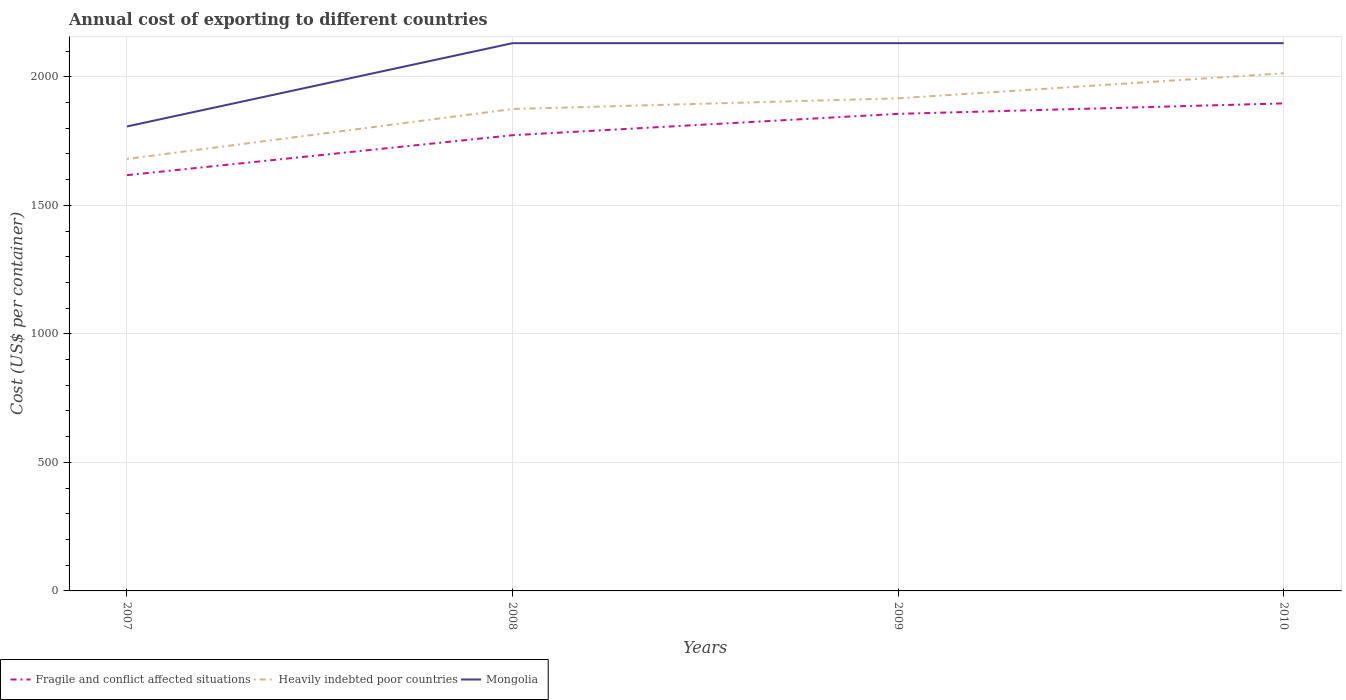Is the number of lines equal to the number of legend labels?
Your answer should be compact. Yes. Across all years, what is the maximum total annual cost of exporting in Mongolia?
Ensure brevity in your answer.  1807. In which year was the total annual cost of exporting in Heavily indebted poor countries maximum?
Your answer should be very brief. 2007. What is the total total annual cost of exporting in Heavily indebted poor countries in the graph?
Offer a very short reply. -235.92. What is the difference between the highest and the second highest total annual cost of exporting in Heavily indebted poor countries?
Your response must be concise. 333.29. Is the total annual cost of exporting in Fragile and conflict affected situations strictly greater than the total annual cost of exporting in Mongolia over the years?
Keep it short and to the point. Yes. How many years are there in the graph?
Offer a very short reply. 4. Does the graph contain any zero values?
Your answer should be very brief. No. Does the graph contain grids?
Your response must be concise. Yes. What is the title of the graph?
Your answer should be compact. Annual cost of exporting to different countries. What is the label or title of the Y-axis?
Provide a short and direct response. Cost (US$ per container). What is the Cost (US$ per container) in Fragile and conflict affected situations in 2007?
Your answer should be very brief. 1617.52. What is the Cost (US$ per container) in Heavily indebted poor countries in 2007?
Provide a short and direct response. 1680.55. What is the Cost (US$ per container) in Mongolia in 2007?
Your answer should be very brief. 1807. What is the Cost (US$ per container) in Fragile and conflict affected situations in 2008?
Ensure brevity in your answer.  1772.86. What is the Cost (US$ per container) in Heavily indebted poor countries in 2008?
Make the answer very short. 1874.84. What is the Cost (US$ per container) in Mongolia in 2008?
Provide a succinct answer. 2131. What is the Cost (US$ per container) in Fragile and conflict affected situations in 2009?
Provide a short and direct response. 1856. What is the Cost (US$ per container) of Heavily indebted poor countries in 2009?
Your answer should be compact. 1916.47. What is the Cost (US$ per container) of Mongolia in 2009?
Your answer should be compact. 2131. What is the Cost (US$ per container) in Fragile and conflict affected situations in 2010?
Provide a short and direct response. 1896.7. What is the Cost (US$ per container) of Heavily indebted poor countries in 2010?
Your response must be concise. 2013.84. What is the Cost (US$ per container) in Mongolia in 2010?
Your answer should be compact. 2131. Across all years, what is the maximum Cost (US$ per container) in Fragile and conflict affected situations?
Your answer should be very brief. 1896.7. Across all years, what is the maximum Cost (US$ per container) of Heavily indebted poor countries?
Provide a succinct answer. 2013.84. Across all years, what is the maximum Cost (US$ per container) in Mongolia?
Offer a very short reply. 2131. Across all years, what is the minimum Cost (US$ per container) of Fragile and conflict affected situations?
Offer a terse response. 1617.52. Across all years, what is the minimum Cost (US$ per container) in Heavily indebted poor countries?
Provide a succinct answer. 1680.55. Across all years, what is the minimum Cost (US$ per container) in Mongolia?
Your answer should be compact. 1807. What is the total Cost (US$ per container) of Fragile and conflict affected situations in the graph?
Offer a terse response. 7143.08. What is the total Cost (US$ per container) in Heavily indebted poor countries in the graph?
Your response must be concise. 7485.71. What is the total Cost (US$ per container) in Mongolia in the graph?
Your answer should be compact. 8200. What is the difference between the Cost (US$ per container) in Fragile and conflict affected situations in 2007 and that in 2008?
Provide a succinct answer. -155.34. What is the difference between the Cost (US$ per container) of Heavily indebted poor countries in 2007 and that in 2008?
Offer a terse response. -194.29. What is the difference between the Cost (US$ per container) of Mongolia in 2007 and that in 2008?
Your response must be concise. -324. What is the difference between the Cost (US$ per container) of Fragile and conflict affected situations in 2007 and that in 2009?
Provide a succinct answer. -238.48. What is the difference between the Cost (US$ per container) of Heavily indebted poor countries in 2007 and that in 2009?
Ensure brevity in your answer.  -235.92. What is the difference between the Cost (US$ per container) of Mongolia in 2007 and that in 2009?
Make the answer very short. -324. What is the difference between the Cost (US$ per container) in Fragile and conflict affected situations in 2007 and that in 2010?
Offer a very short reply. -279.18. What is the difference between the Cost (US$ per container) of Heavily indebted poor countries in 2007 and that in 2010?
Offer a very short reply. -333.29. What is the difference between the Cost (US$ per container) in Mongolia in 2007 and that in 2010?
Your answer should be compact. -324. What is the difference between the Cost (US$ per container) of Fragile and conflict affected situations in 2008 and that in 2009?
Provide a short and direct response. -83.14. What is the difference between the Cost (US$ per container) in Heavily indebted poor countries in 2008 and that in 2009?
Your answer should be very brief. -41.63. What is the difference between the Cost (US$ per container) in Fragile and conflict affected situations in 2008 and that in 2010?
Provide a succinct answer. -123.84. What is the difference between the Cost (US$ per container) in Heavily indebted poor countries in 2008 and that in 2010?
Provide a short and direct response. -139. What is the difference between the Cost (US$ per container) of Fragile and conflict affected situations in 2009 and that in 2010?
Make the answer very short. -40.7. What is the difference between the Cost (US$ per container) of Heavily indebted poor countries in 2009 and that in 2010?
Provide a succinct answer. -97.37. What is the difference between the Cost (US$ per container) in Fragile and conflict affected situations in 2007 and the Cost (US$ per container) in Heavily indebted poor countries in 2008?
Ensure brevity in your answer.  -257.32. What is the difference between the Cost (US$ per container) of Fragile and conflict affected situations in 2007 and the Cost (US$ per container) of Mongolia in 2008?
Provide a short and direct response. -513.48. What is the difference between the Cost (US$ per container) in Heavily indebted poor countries in 2007 and the Cost (US$ per container) in Mongolia in 2008?
Your answer should be very brief. -450.45. What is the difference between the Cost (US$ per container) in Fragile and conflict affected situations in 2007 and the Cost (US$ per container) in Heavily indebted poor countries in 2009?
Provide a short and direct response. -298.96. What is the difference between the Cost (US$ per container) in Fragile and conflict affected situations in 2007 and the Cost (US$ per container) in Mongolia in 2009?
Provide a short and direct response. -513.48. What is the difference between the Cost (US$ per container) in Heavily indebted poor countries in 2007 and the Cost (US$ per container) in Mongolia in 2009?
Your answer should be very brief. -450.45. What is the difference between the Cost (US$ per container) of Fragile and conflict affected situations in 2007 and the Cost (US$ per container) of Heavily indebted poor countries in 2010?
Provide a short and direct response. -396.32. What is the difference between the Cost (US$ per container) in Fragile and conflict affected situations in 2007 and the Cost (US$ per container) in Mongolia in 2010?
Your response must be concise. -513.48. What is the difference between the Cost (US$ per container) of Heavily indebted poor countries in 2007 and the Cost (US$ per container) of Mongolia in 2010?
Provide a short and direct response. -450.45. What is the difference between the Cost (US$ per container) of Fragile and conflict affected situations in 2008 and the Cost (US$ per container) of Heavily indebted poor countries in 2009?
Ensure brevity in your answer.  -143.61. What is the difference between the Cost (US$ per container) of Fragile and conflict affected situations in 2008 and the Cost (US$ per container) of Mongolia in 2009?
Your answer should be very brief. -358.14. What is the difference between the Cost (US$ per container) in Heavily indebted poor countries in 2008 and the Cost (US$ per container) in Mongolia in 2009?
Your response must be concise. -256.16. What is the difference between the Cost (US$ per container) of Fragile and conflict affected situations in 2008 and the Cost (US$ per container) of Heavily indebted poor countries in 2010?
Make the answer very short. -240.98. What is the difference between the Cost (US$ per container) of Fragile and conflict affected situations in 2008 and the Cost (US$ per container) of Mongolia in 2010?
Your response must be concise. -358.14. What is the difference between the Cost (US$ per container) in Heavily indebted poor countries in 2008 and the Cost (US$ per container) in Mongolia in 2010?
Keep it short and to the point. -256.16. What is the difference between the Cost (US$ per container) of Fragile and conflict affected situations in 2009 and the Cost (US$ per container) of Heavily indebted poor countries in 2010?
Offer a very short reply. -157.84. What is the difference between the Cost (US$ per container) in Fragile and conflict affected situations in 2009 and the Cost (US$ per container) in Mongolia in 2010?
Ensure brevity in your answer.  -275. What is the difference between the Cost (US$ per container) of Heavily indebted poor countries in 2009 and the Cost (US$ per container) of Mongolia in 2010?
Make the answer very short. -214.53. What is the average Cost (US$ per container) of Fragile and conflict affected situations per year?
Provide a short and direct response. 1785.77. What is the average Cost (US$ per container) of Heavily indebted poor countries per year?
Provide a short and direct response. 1871.43. What is the average Cost (US$ per container) in Mongolia per year?
Your answer should be compact. 2050. In the year 2007, what is the difference between the Cost (US$ per container) in Fragile and conflict affected situations and Cost (US$ per container) in Heavily indebted poor countries?
Offer a terse response. -63.04. In the year 2007, what is the difference between the Cost (US$ per container) of Fragile and conflict affected situations and Cost (US$ per container) of Mongolia?
Offer a very short reply. -189.48. In the year 2007, what is the difference between the Cost (US$ per container) in Heavily indebted poor countries and Cost (US$ per container) in Mongolia?
Give a very brief answer. -126.45. In the year 2008, what is the difference between the Cost (US$ per container) in Fragile and conflict affected situations and Cost (US$ per container) in Heavily indebted poor countries?
Your answer should be compact. -101.98. In the year 2008, what is the difference between the Cost (US$ per container) of Fragile and conflict affected situations and Cost (US$ per container) of Mongolia?
Your response must be concise. -358.14. In the year 2008, what is the difference between the Cost (US$ per container) of Heavily indebted poor countries and Cost (US$ per container) of Mongolia?
Give a very brief answer. -256.16. In the year 2009, what is the difference between the Cost (US$ per container) of Fragile and conflict affected situations and Cost (US$ per container) of Heavily indebted poor countries?
Provide a short and direct response. -60.47. In the year 2009, what is the difference between the Cost (US$ per container) of Fragile and conflict affected situations and Cost (US$ per container) of Mongolia?
Give a very brief answer. -275. In the year 2009, what is the difference between the Cost (US$ per container) in Heavily indebted poor countries and Cost (US$ per container) in Mongolia?
Your response must be concise. -214.53. In the year 2010, what is the difference between the Cost (US$ per container) in Fragile and conflict affected situations and Cost (US$ per container) in Heavily indebted poor countries?
Make the answer very short. -117.14. In the year 2010, what is the difference between the Cost (US$ per container) in Fragile and conflict affected situations and Cost (US$ per container) in Mongolia?
Offer a very short reply. -234.3. In the year 2010, what is the difference between the Cost (US$ per container) in Heavily indebted poor countries and Cost (US$ per container) in Mongolia?
Your answer should be very brief. -117.16. What is the ratio of the Cost (US$ per container) in Fragile and conflict affected situations in 2007 to that in 2008?
Make the answer very short. 0.91. What is the ratio of the Cost (US$ per container) of Heavily indebted poor countries in 2007 to that in 2008?
Provide a succinct answer. 0.9. What is the ratio of the Cost (US$ per container) in Mongolia in 2007 to that in 2008?
Provide a short and direct response. 0.85. What is the ratio of the Cost (US$ per container) in Fragile and conflict affected situations in 2007 to that in 2009?
Ensure brevity in your answer.  0.87. What is the ratio of the Cost (US$ per container) of Heavily indebted poor countries in 2007 to that in 2009?
Your answer should be compact. 0.88. What is the ratio of the Cost (US$ per container) in Mongolia in 2007 to that in 2009?
Offer a terse response. 0.85. What is the ratio of the Cost (US$ per container) of Fragile and conflict affected situations in 2007 to that in 2010?
Keep it short and to the point. 0.85. What is the ratio of the Cost (US$ per container) of Heavily indebted poor countries in 2007 to that in 2010?
Offer a terse response. 0.83. What is the ratio of the Cost (US$ per container) in Mongolia in 2007 to that in 2010?
Give a very brief answer. 0.85. What is the ratio of the Cost (US$ per container) of Fragile and conflict affected situations in 2008 to that in 2009?
Provide a succinct answer. 0.96. What is the ratio of the Cost (US$ per container) in Heavily indebted poor countries in 2008 to that in 2009?
Offer a very short reply. 0.98. What is the ratio of the Cost (US$ per container) of Fragile and conflict affected situations in 2008 to that in 2010?
Provide a succinct answer. 0.93. What is the ratio of the Cost (US$ per container) in Heavily indebted poor countries in 2008 to that in 2010?
Offer a terse response. 0.93. What is the ratio of the Cost (US$ per container) of Fragile and conflict affected situations in 2009 to that in 2010?
Provide a short and direct response. 0.98. What is the ratio of the Cost (US$ per container) in Heavily indebted poor countries in 2009 to that in 2010?
Ensure brevity in your answer.  0.95. What is the difference between the highest and the second highest Cost (US$ per container) in Fragile and conflict affected situations?
Your answer should be very brief. 40.7. What is the difference between the highest and the second highest Cost (US$ per container) of Heavily indebted poor countries?
Provide a short and direct response. 97.37. What is the difference between the highest and the second highest Cost (US$ per container) in Mongolia?
Provide a short and direct response. 0. What is the difference between the highest and the lowest Cost (US$ per container) in Fragile and conflict affected situations?
Your response must be concise. 279.18. What is the difference between the highest and the lowest Cost (US$ per container) of Heavily indebted poor countries?
Offer a very short reply. 333.29. What is the difference between the highest and the lowest Cost (US$ per container) of Mongolia?
Provide a short and direct response. 324. 